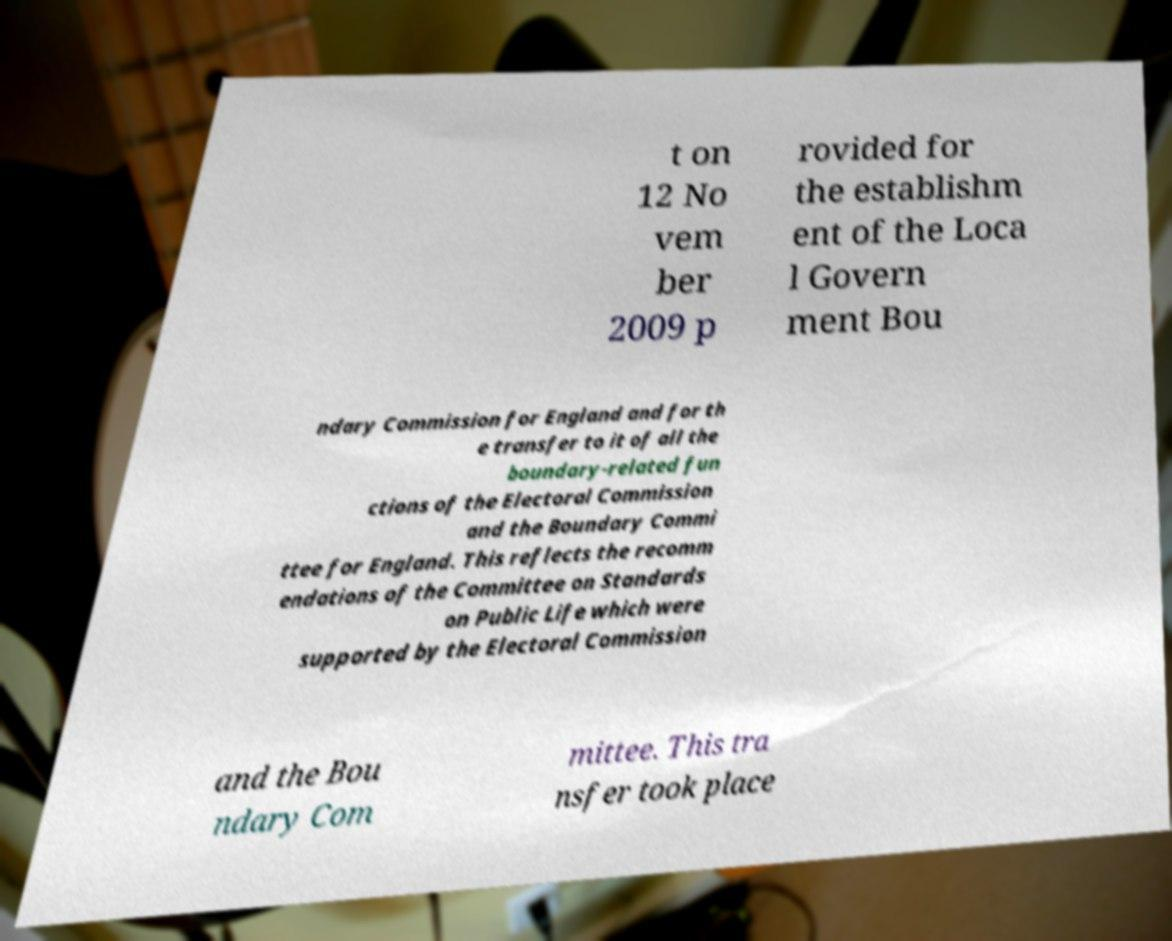There's text embedded in this image that I need extracted. Can you transcribe it verbatim? t on 12 No vem ber 2009 p rovided for the establishm ent of the Loca l Govern ment Bou ndary Commission for England and for th e transfer to it of all the boundary-related fun ctions of the Electoral Commission and the Boundary Commi ttee for England. This reflects the recomm endations of the Committee on Standards on Public Life which were supported by the Electoral Commission and the Bou ndary Com mittee. This tra nsfer took place 